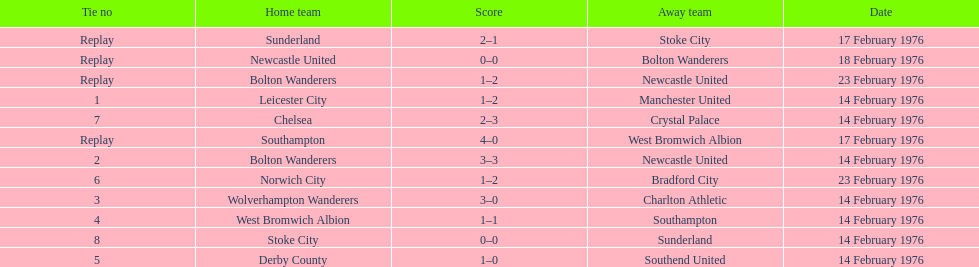How many of these games occurred before 17 february 1976? 7. 